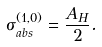Convert formula to latex. <formula><loc_0><loc_0><loc_500><loc_500>\sigma _ { a b s } ^ { ( 1 , 0 ) } = \frac { A _ { H } } { 2 } .</formula> 